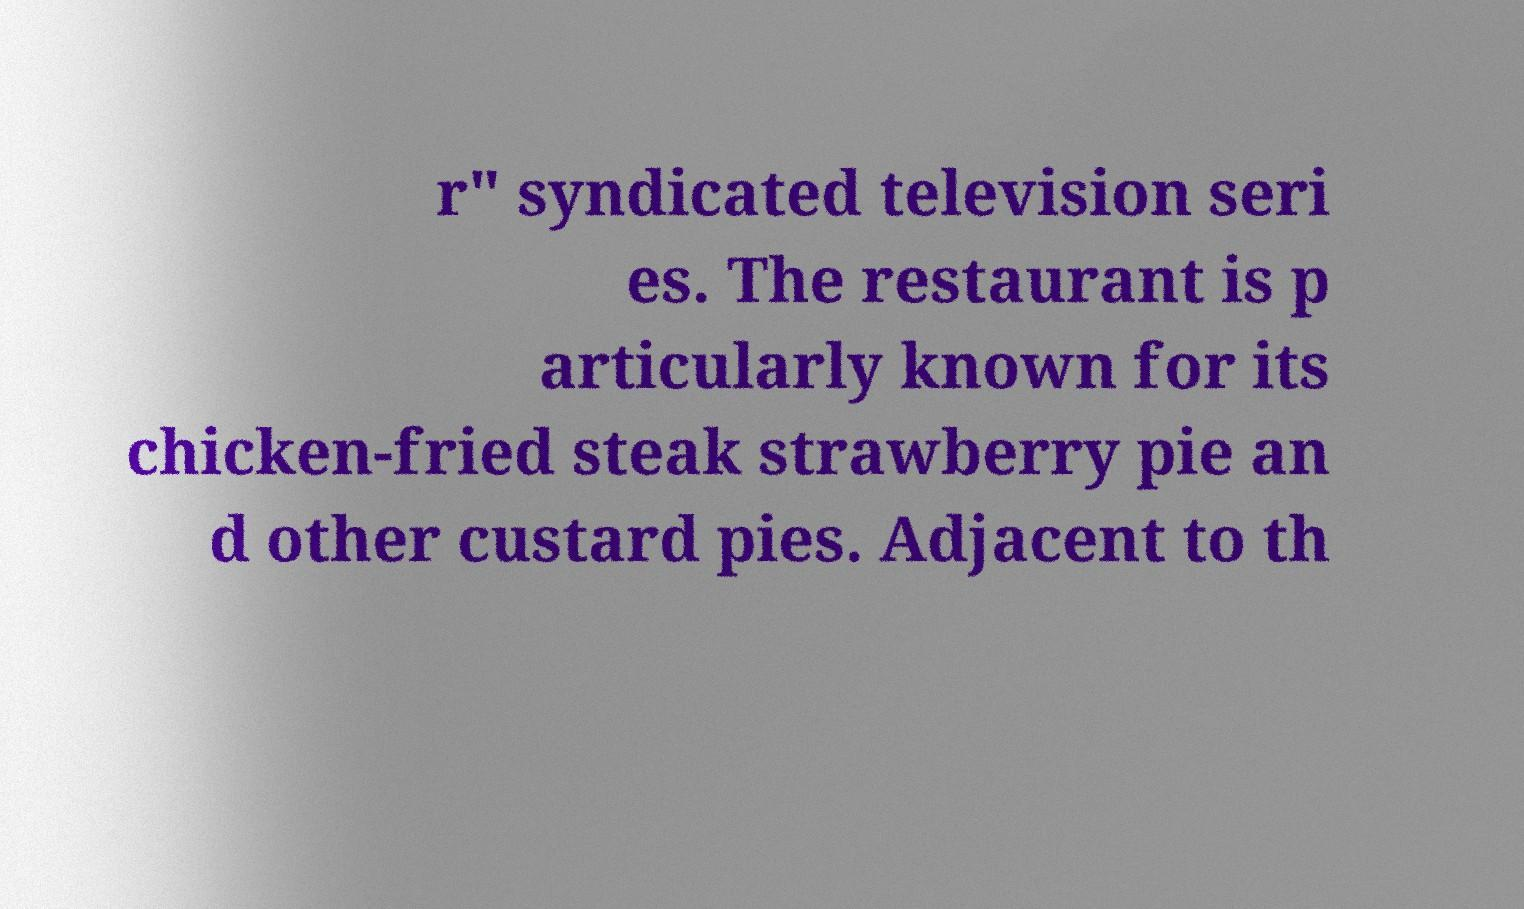I need the written content from this picture converted into text. Can you do that? r" syndicated television seri es. The restaurant is p articularly known for its chicken-fried steak strawberry pie an d other custard pies. Adjacent to th 